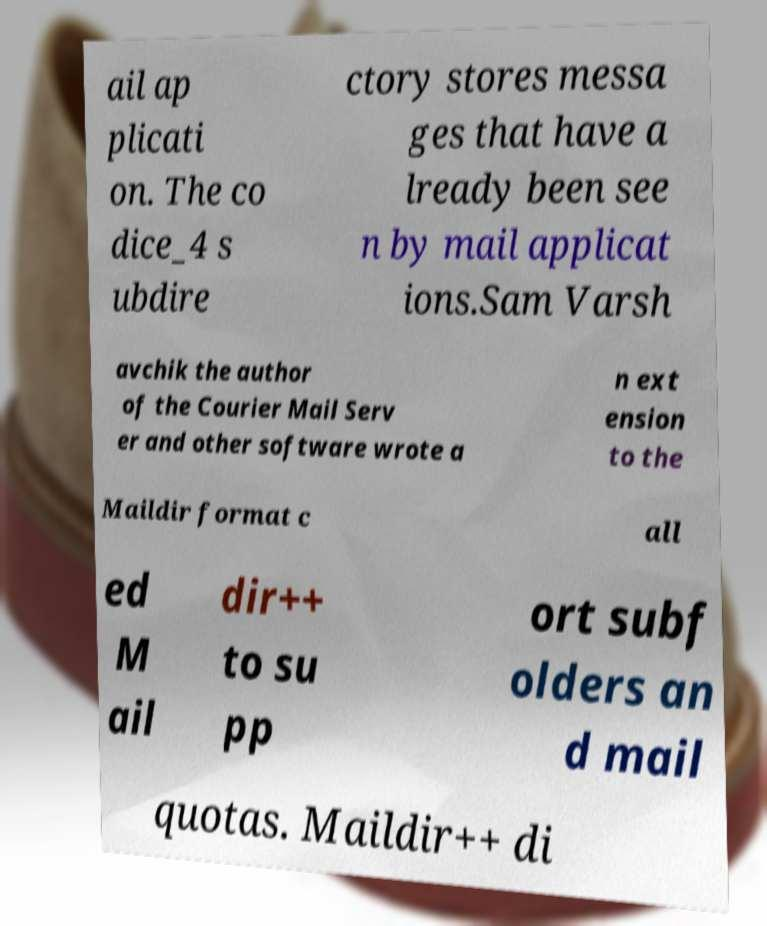Please read and relay the text visible in this image. What does it say? ail ap plicati on. The co dice_4 s ubdire ctory stores messa ges that have a lready been see n by mail applicat ions.Sam Varsh avchik the author of the Courier Mail Serv er and other software wrote a n ext ension to the Maildir format c all ed M ail dir++ to su pp ort subf olders an d mail quotas. Maildir++ di 